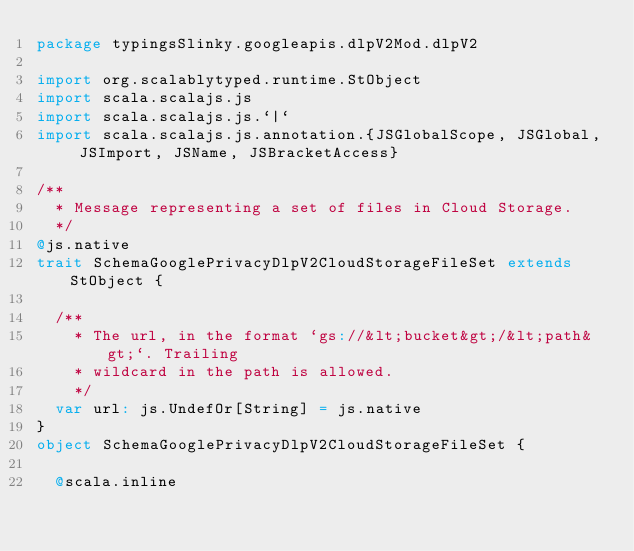Convert code to text. <code><loc_0><loc_0><loc_500><loc_500><_Scala_>package typingsSlinky.googleapis.dlpV2Mod.dlpV2

import org.scalablytyped.runtime.StObject
import scala.scalajs.js
import scala.scalajs.js.`|`
import scala.scalajs.js.annotation.{JSGlobalScope, JSGlobal, JSImport, JSName, JSBracketAccess}

/**
  * Message representing a set of files in Cloud Storage.
  */
@js.native
trait SchemaGooglePrivacyDlpV2CloudStorageFileSet extends StObject {
  
  /**
    * The url, in the format `gs://&lt;bucket&gt;/&lt;path&gt;`. Trailing
    * wildcard in the path is allowed.
    */
  var url: js.UndefOr[String] = js.native
}
object SchemaGooglePrivacyDlpV2CloudStorageFileSet {
  
  @scala.inline</code> 